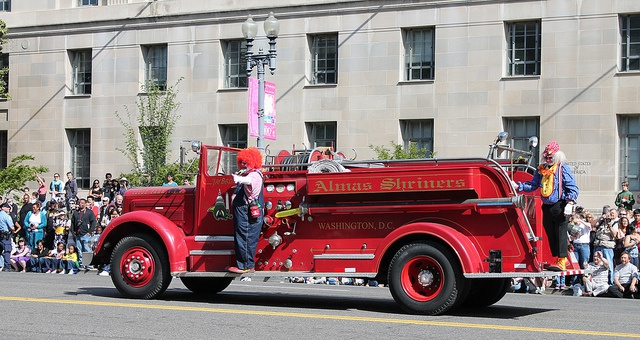Describe the objects in this image and their specific colors. I can see truck in darkgray, black, maroon, and brown tones, people in darkgray, black, gray, and lightgray tones, people in darkgray, black, lightgray, navy, and gray tones, people in darkgray, black, gray, lavender, and darkblue tones, and people in darkgray, black, lightgray, and gray tones in this image. 